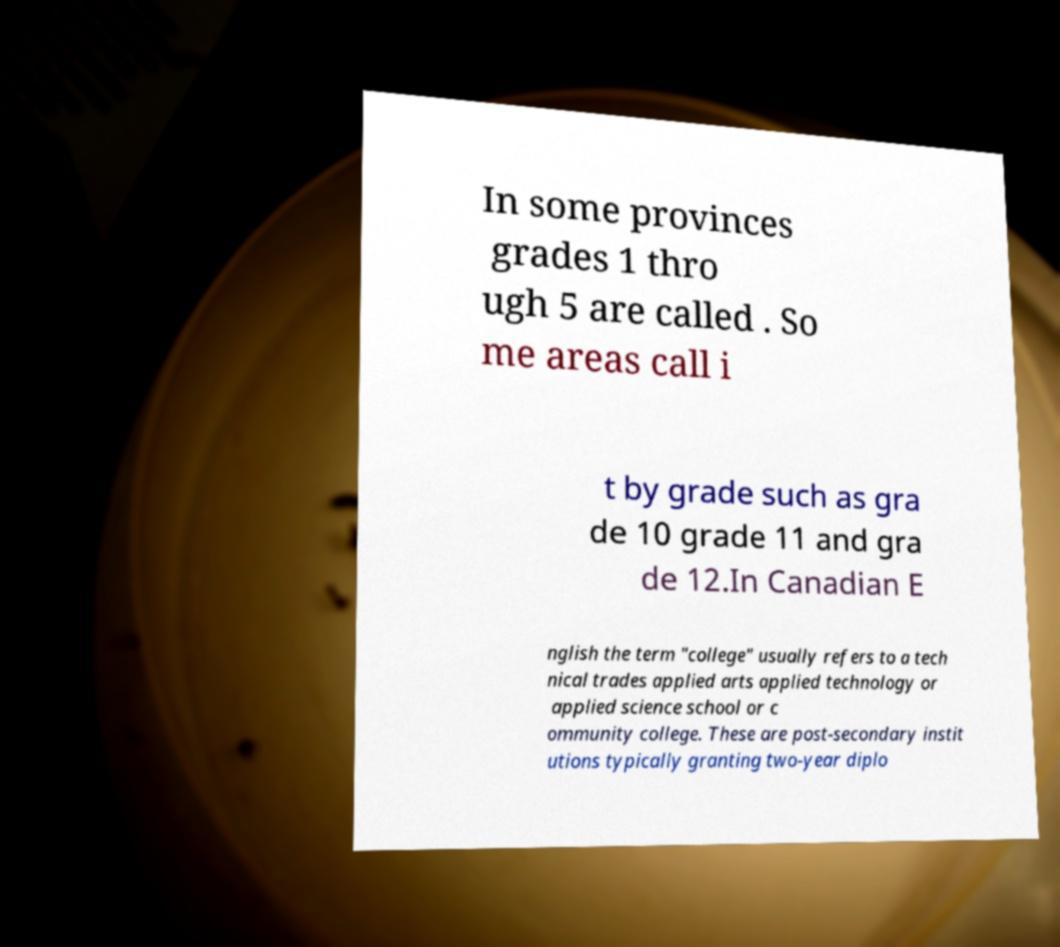Please identify and transcribe the text found in this image. In some provinces grades 1 thro ugh 5 are called . So me areas call i t by grade such as gra de 10 grade 11 and gra de 12.In Canadian E nglish the term "college" usually refers to a tech nical trades applied arts applied technology or applied science school or c ommunity college. These are post-secondary instit utions typically granting two-year diplo 